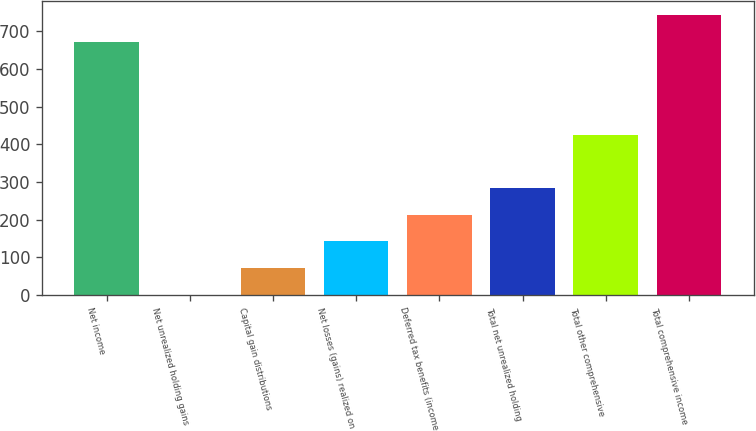Convert chart to OTSL. <chart><loc_0><loc_0><loc_500><loc_500><bar_chart><fcel>Net income<fcel>Net unrealized holding gains<fcel>Capital gain distributions<fcel>Net losses (gains) realized on<fcel>Deferred tax benefits (income<fcel>Total net unrealized holding<fcel>Total other comprehensive<fcel>Total comprehensive income<nl><fcel>672.2<fcel>0.1<fcel>71.03<fcel>141.96<fcel>212.89<fcel>283.82<fcel>425.68<fcel>743.13<nl></chart> 